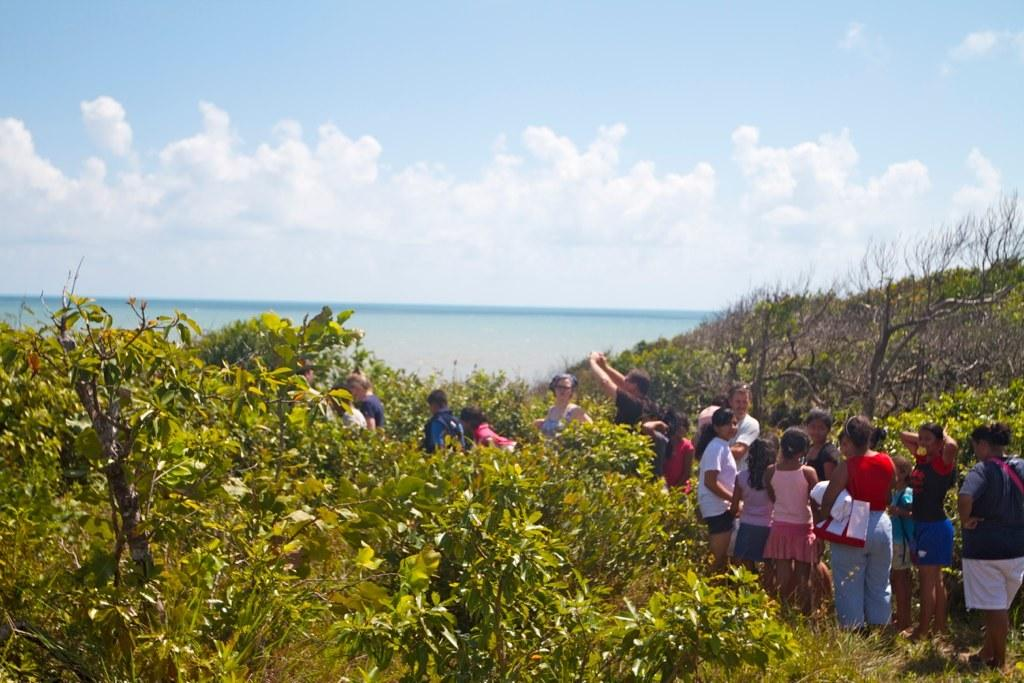What is happening in the image? There are people standing in the image. What type of vegetation can be seen in the image? There are plants and trees in the image. What can be seen in the background of the image? The sky, clouds, and water are visible in the background of the image. Where is the sofa located in the image? There is no sofa present in the image. What type of joke is being told by the people in the image? There is no indication of a joke being told in the image. 